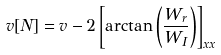<formula> <loc_0><loc_0><loc_500><loc_500>v [ N ] = v - 2 \left [ \arctan \left ( \frac { W _ { r } } { W _ { I } } \right ) \right ] _ { x x }</formula> 